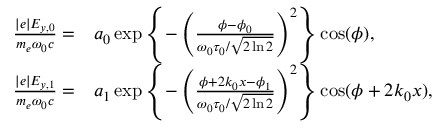Convert formula to latex. <formula><loc_0><loc_0><loc_500><loc_500>\begin{array} { r l } { \frac { | e | E _ { y , 0 } } { m _ { e } \omega _ { 0 } c } = } & a _ { 0 } \exp \left \{ - \left ( \frac { \phi - \phi _ { 0 } } { \omega _ { 0 } \tau _ { 0 } / \sqrt { 2 \ln 2 } } \right ) ^ { 2 } \right \} \cos ( \phi ) , } \\ { \frac { | e | E _ { y , 1 } } { m _ { e } \omega _ { 0 } c } = } & a _ { 1 } \exp \left \{ - \left ( \frac { \phi + 2 k _ { 0 } x - \phi _ { 1 } } { \omega _ { 0 } \tau _ { 0 } / \sqrt { 2 \ln 2 } } \right ) ^ { 2 } \right \} \cos ( \phi + 2 k _ { 0 } x ) , } \end{array}</formula> 